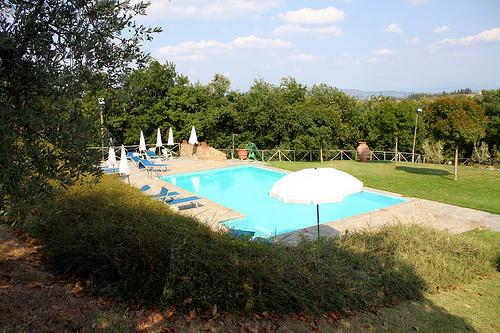Question: how many people are swimming in the pool?
Choices:
A. One.
B. Zero.
C. Two.
D. Three.
Answer with the letter. Answer: B Question: what item is next to each umbrella?
Choices:
A. A suitcase.
B. A raincoat.
C. Chair.
D. Boots.
Answer with the letter. Answer: C Question: why is the umbrella open?
Choices:
A. Shade.
B. It's raining.
C. It's snowing.
D. It's hailing.
Answer with the letter. Answer: A Question: who is underneath the umbrella?
Choices:
A. The children.
B. The lifeguard.
C. No one.
D. The driver.
Answer with the letter. Answer: C 